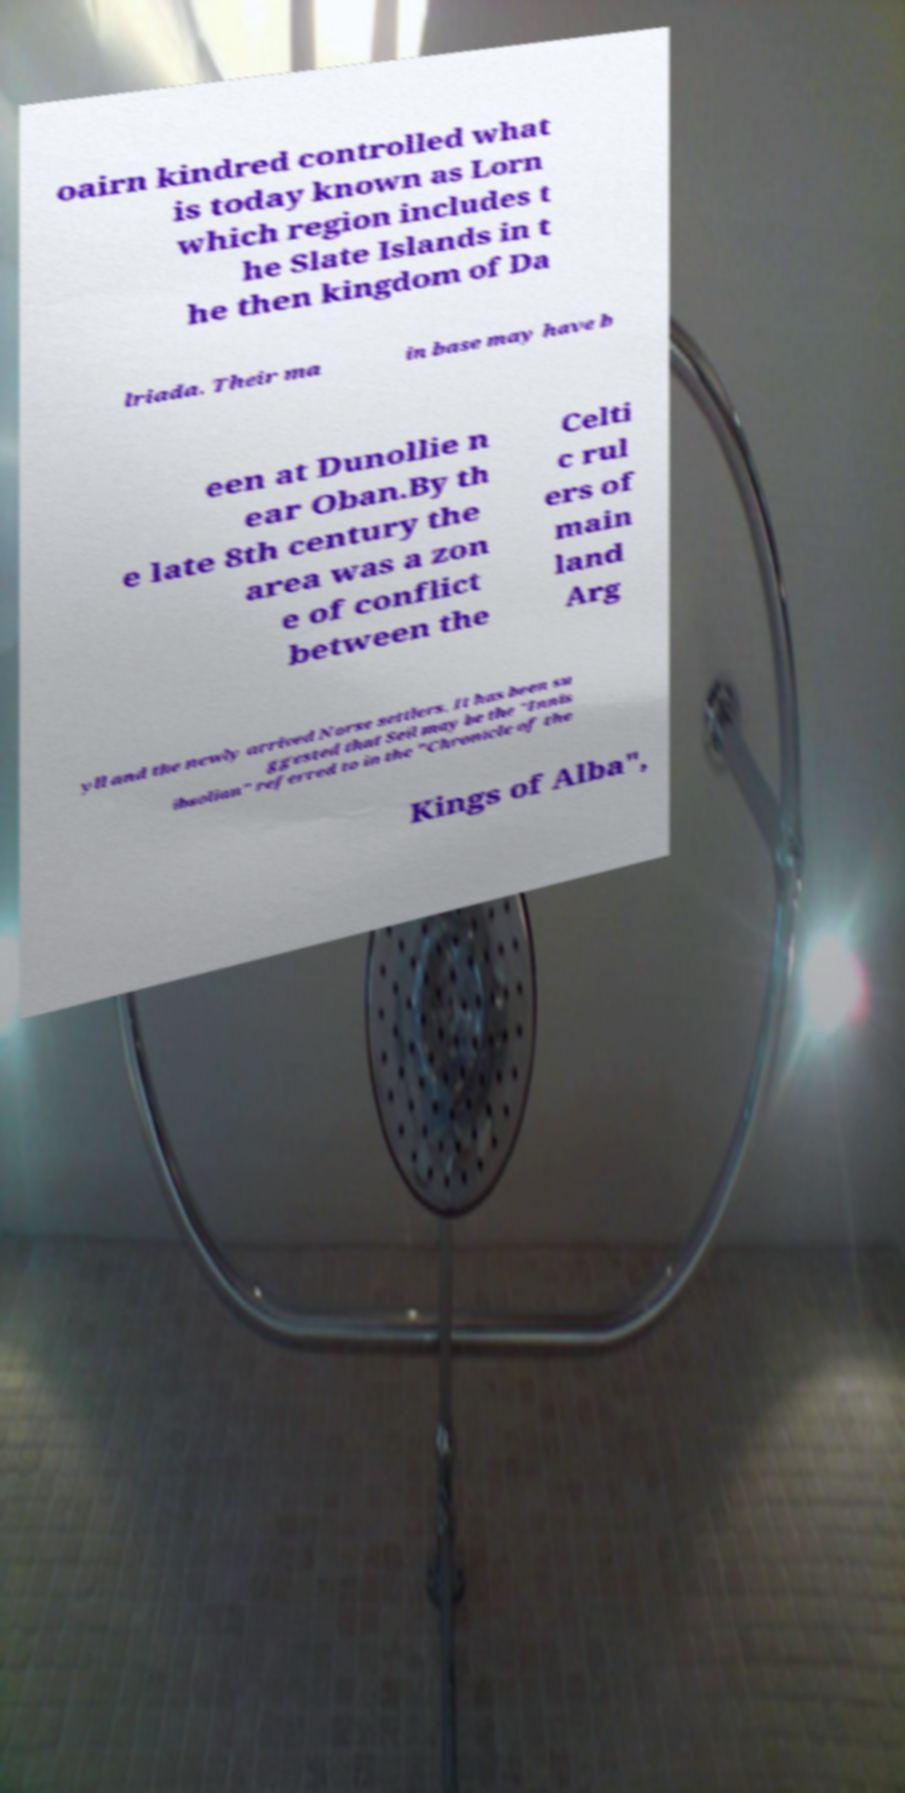Please identify and transcribe the text found in this image. oairn kindred controlled what is today known as Lorn which region includes t he Slate Islands in t he then kingdom of Da lriada. Their ma in base may have b een at Dunollie n ear Oban.By th e late 8th century the area was a zon e of conflict between the Celti c rul ers of main land Arg yll and the newly arrived Norse settlers. It has been su ggested that Seil may be the "Innis ibsolian" referred to in the "Chronicle of the Kings of Alba", 